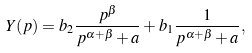Convert formula to latex. <formula><loc_0><loc_0><loc_500><loc_500>Y ( p ) = b _ { 2 } \frac { p ^ { \beta } } { p ^ { \alpha + \beta } + a } + b _ { 1 } \frac { 1 } { p ^ { \alpha + \beta } + a } ,</formula> 